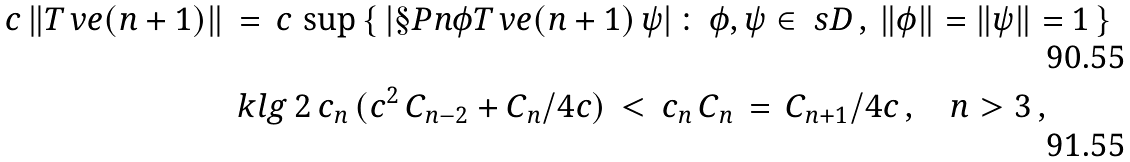Convert formula to latex. <formula><loc_0><loc_0><loc_500><loc_500>c \, \| T _ { \ } v e ( n + 1 ) \| \, & = \, c \, \sup \left \{ \, | \S P n { \phi } { T _ { \ } v e ( n + 1 ) \, \psi } | \, \colon \, \phi , \psi \in \ s D \, , \, \| \phi \| = \| \psi \| = 1 \, \right \} \\ & \ k l g \, 2 \, c _ { n } \, ( c ^ { 2 } \, C _ { n - 2 } + C _ { n } / 4 c ) \, < \, c _ { n } \, C _ { n } \, = \, C _ { n + 1 } / 4 c \, , \quad n > 3 \, ,</formula> 